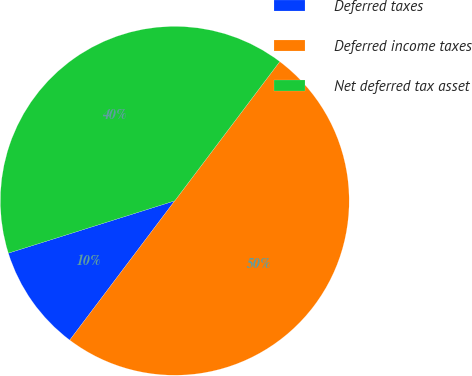Convert chart to OTSL. <chart><loc_0><loc_0><loc_500><loc_500><pie_chart><fcel>Deferred taxes<fcel>Deferred income taxes<fcel>Net deferred tax asset<nl><fcel>9.87%<fcel>50.0%<fcel>40.13%<nl></chart> 